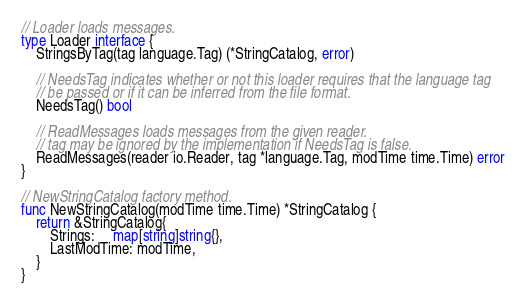<code> <loc_0><loc_0><loc_500><loc_500><_Go_>
// Loader loads messages.
type Loader interface {
	StringsByTag(tag language.Tag) (*StringCatalog, error)

	// NeedsTag indicates whether or not this loader requires that the language tag
	// be passed or if it can be inferred from the file format.
	NeedsTag() bool

	// ReadMessages loads messages from the given reader.
	// tag may be ignored by the implementation if NeedsTag is false.
	ReadMessages(reader io.Reader, tag *language.Tag, modTime time.Time) error
}

// NewStringCatalog factory method.
func NewStringCatalog(modTime time.Time) *StringCatalog {
	return &StringCatalog{
		Strings:     map[string]string{},
		LastModTime: modTime,
	}
}
</code> 